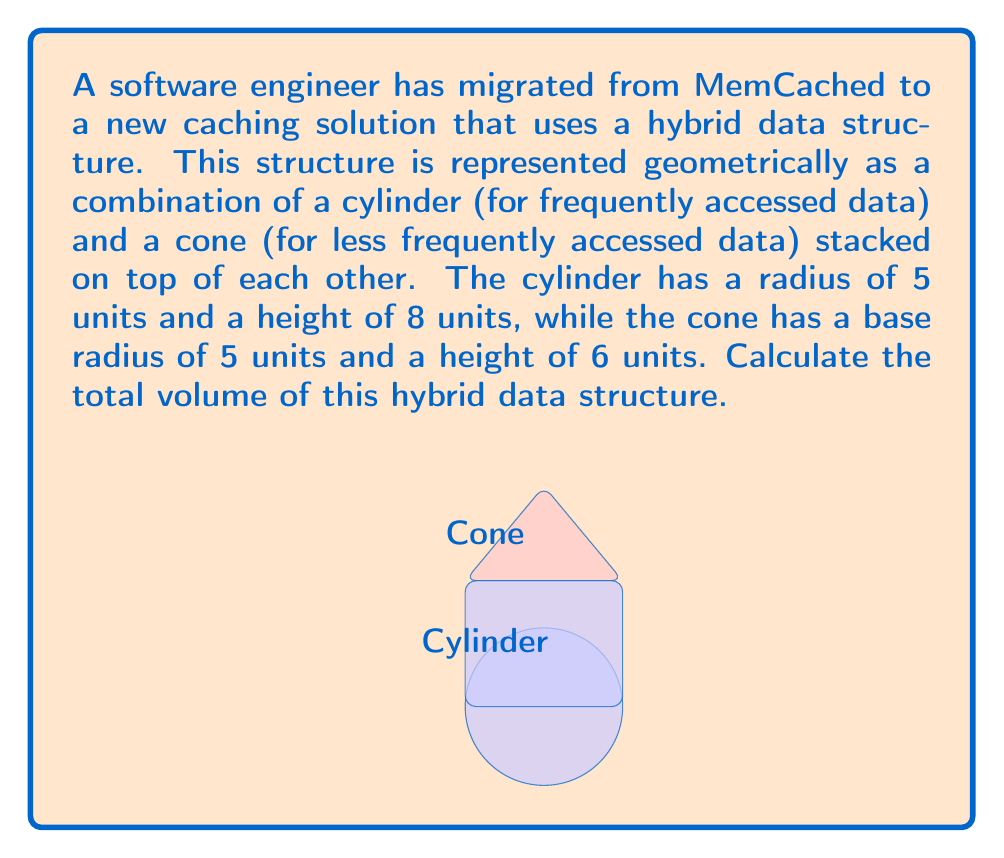Give your solution to this math problem. To solve this problem, we need to calculate the volumes of both the cylinder and the cone, then sum them up. Let's break it down step-by-step:

1. Volume of a cylinder:
   The formula for the volume of a cylinder is $V_{cylinder} = \pi r^2 h$
   where $r$ is the radius and $h$ is the height.
   
   $V_{cylinder} = \pi (5^2) (8) = 200\pi$ cubic units

2. Volume of a cone:
   The formula for the volume of a cone is $V_{cone} = \frac{1}{3} \pi r^2 h$
   where $r$ is the radius of the base and $h$ is the height.
   
   $V_{cone} = \frac{1}{3} \pi (5^2) (6) = 50\pi$ cubic units

3. Total volume:
   The total volume is the sum of the volumes of the cylinder and the cone.
   
   $V_{total} = V_{cylinder} + V_{cone}$
   $V_{total} = 200\pi + 50\pi = 250\pi$ cubic units

Therefore, the total volume of the hybrid data structure is $250\pi$ cubic units.
Answer: $250\pi$ cubic units 